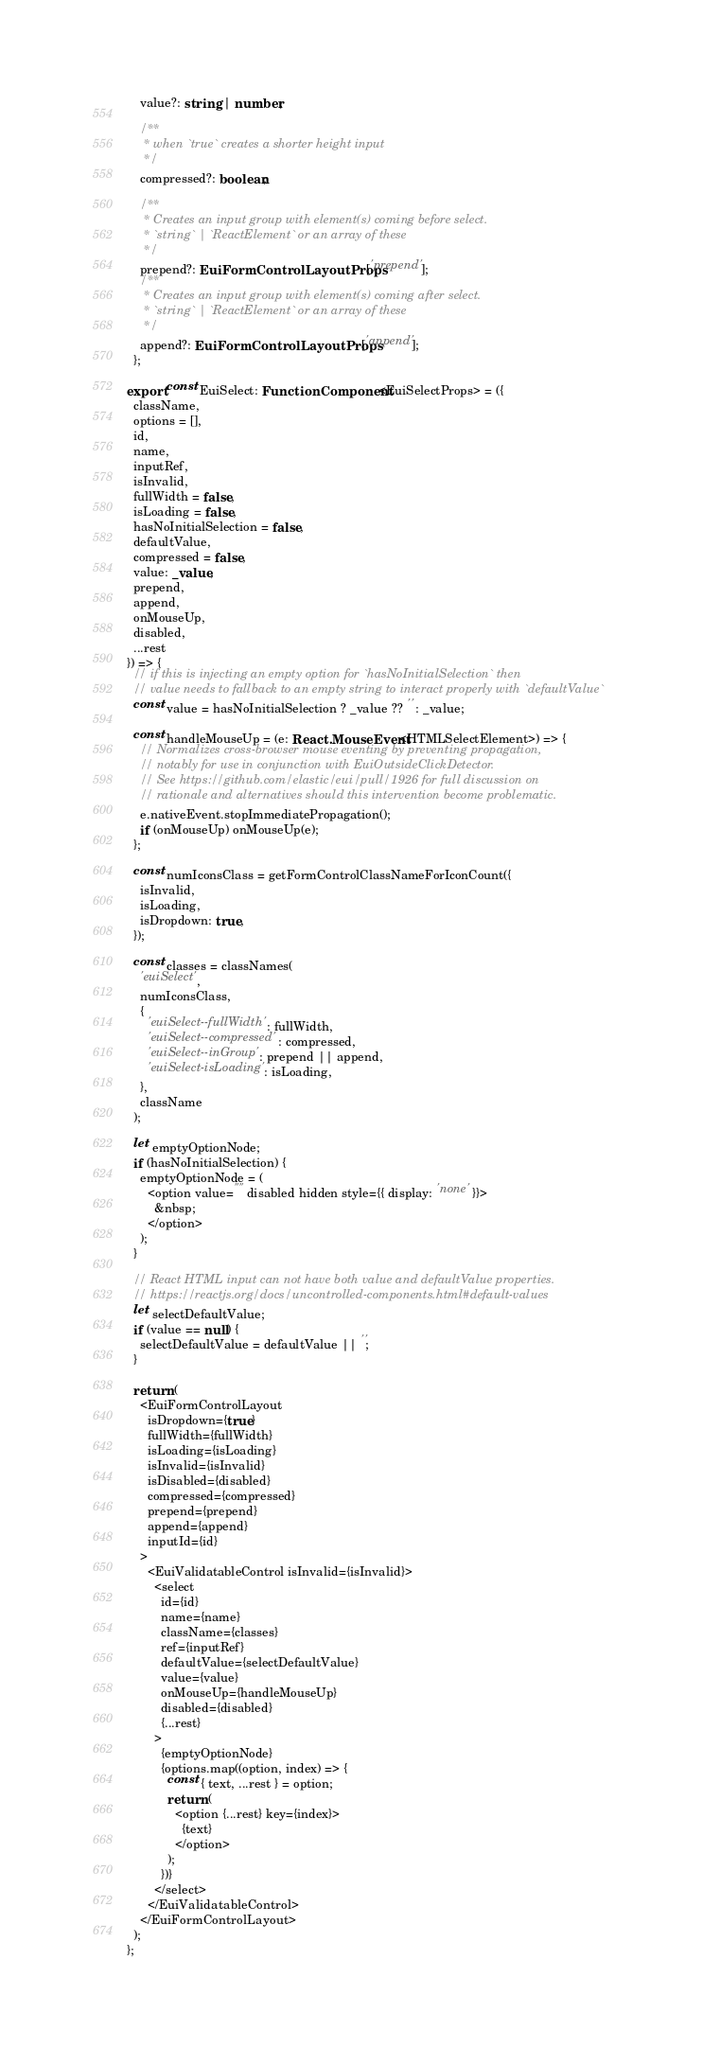<code> <loc_0><loc_0><loc_500><loc_500><_TypeScript_>    value?: string | number;

    /**
     * when `true` creates a shorter height input
     */
    compressed?: boolean;

    /**
     * Creates an input group with element(s) coming before select.
     * `string` | `ReactElement` or an array of these
     */
    prepend?: EuiFormControlLayoutProps['prepend'];
    /**
     * Creates an input group with element(s) coming after select.
     * `string` | `ReactElement` or an array of these
     */
    append?: EuiFormControlLayoutProps['append'];
  };

export const EuiSelect: FunctionComponent<EuiSelectProps> = ({
  className,
  options = [],
  id,
  name,
  inputRef,
  isInvalid,
  fullWidth = false,
  isLoading = false,
  hasNoInitialSelection = false,
  defaultValue,
  compressed = false,
  value: _value,
  prepend,
  append,
  onMouseUp,
  disabled,
  ...rest
}) => {
  // if this is injecting an empty option for `hasNoInitialSelection` then
  // value needs to fallback to an empty string to interact properly with `defaultValue`
  const value = hasNoInitialSelection ? _value ?? '' : _value;

  const handleMouseUp = (e: React.MouseEvent<HTMLSelectElement>) => {
    // Normalizes cross-browser mouse eventing by preventing propagation,
    // notably for use in conjunction with EuiOutsideClickDetector.
    // See https://github.com/elastic/eui/pull/1926 for full discussion on
    // rationale and alternatives should this intervention become problematic.
    e.nativeEvent.stopImmediatePropagation();
    if (onMouseUp) onMouseUp(e);
  };

  const numIconsClass = getFormControlClassNameForIconCount({
    isInvalid,
    isLoading,
    isDropdown: true,
  });

  const classes = classNames(
    'euiSelect',
    numIconsClass,
    {
      'euiSelect--fullWidth': fullWidth,
      'euiSelect--compressed': compressed,
      'euiSelect--inGroup': prepend || append,
      'euiSelect-isLoading': isLoading,
    },
    className
  );

  let emptyOptionNode;
  if (hasNoInitialSelection) {
    emptyOptionNode = (
      <option value="" disabled hidden style={{ display: 'none' }}>
        &nbsp;
      </option>
    );
  }

  // React HTML input can not have both value and defaultValue properties.
  // https://reactjs.org/docs/uncontrolled-components.html#default-values
  let selectDefaultValue;
  if (value == null) {
    selectDefaultValue = defaultValue || '';
  }

  return (
    <EuiFormControlLayout
      isDropdown={true}
      fullWidth={fullWidth}
      isLoading={isLoading}
      isInvalid={isInvalid}
      isDisabled={disabled}
      compressed={compressed}
      prepend={prepend}
      append={append}
      inputId={id}
    >
      <EuiValidatableControl isInvalid={isInvalid}>
        <select
          id={id}
          name={name}
          className={classes}
          ref={inputRef}
          defaultValue={selectDefaultValue}
          value={value}
          onMouseUp={handleMouseUp}
          disabled={disabled}
          {...rest}
        >
          {emptyOptionNode}
          {options.map((option, index) => {
            const { text, ...rest } = option;
            return (
              <option {...rest} key={index}>
                {text}
              </option>
            );
          })}
        </select>
      </EuiValidatableControl>
    </EuiFormControlLayout>
  );
};
</code> 